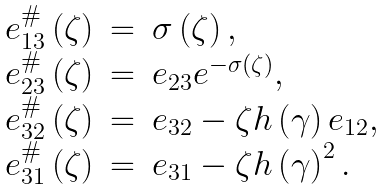<formula> <loc_0><loc_0><loc_500><loc_500>\begin{array} { r c l } e _ { 1 3 } ^ { \# } \left ( \zeta \right ) & = & \sigma \left ( \zeta \right ) , \\ e _ { 2 3 } ^ { \# } \left ( \zeta \right ) & = & e _ { 2 3 } e ^ { - \sigma \left ( \zeta \right ) } , \\ e _ { 3 2 } ^ { \# } \left ( \zeta \right ) & = & e _ { 3 2 } - \zeta h \left ( \gamma \right ) e _ { 1 2 } , \\ e _ { 3 1 } ^ { \# } \left ( \zeta \right ) & = & e _ { 3 1 } - \zeta h \left ( \gamma \right ) ^ { 2 } . \end{array}</formula> 